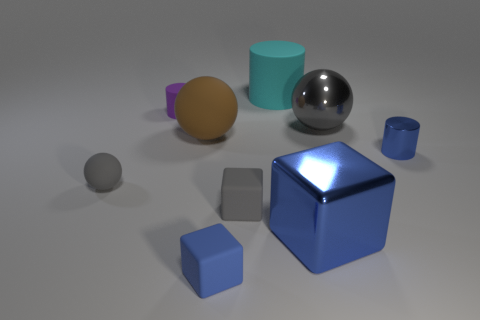Is there a large brown matte thing of the same shape as the purple matte object?
Provide a succinct answer. No. There is a sphere that is left of the small cylinder that is to the left of the shiny thing behind the blue metal cylinder; what color is it?
Your response must be concise. Gray. What number of rubber things are either big blue balls or big things?
Your answer should be compact. 2. Are there more big shiny objects left of the blue rubber thing than large cyan rubber objects that are to the left of the small gray rubber cube?
Keep it short and to the point. No. How many other objects are there of the same size as the blue cylinder?
Your response must be concise. 4. How big is the blue shiny object that is to the left of the sphere that is on the right side of the tiny gray block?
Offer a very short reply. Large. How many large objects are either red metal things or shiny things?
Give a very brief answer. 2. There is a gray matte thing on the right side of the blue thing in front of the large metal thing in front of the large brown sphere; what size is it?
Your response must be concise. Small. Is there any other thing that has the same color as the small rubber sphere?
Offer a terse response. Yes. There is a large ball on the right side of the metal thing that is to the left of the gray object that is behind the large matte sphere; what is it made of?
Keep it short and to the point. Metal. 